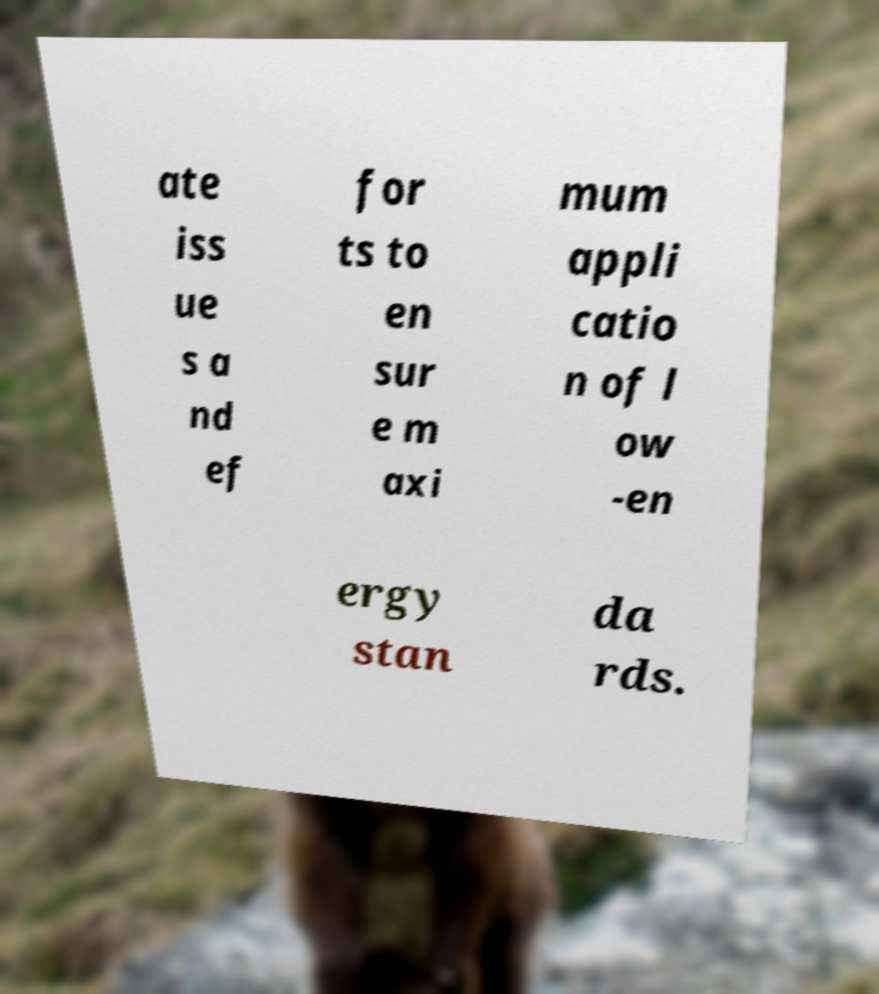Could you assist in decoding the text presented in this image and type it out clearly? ate iss ue s a nd ef for ts to en sur e m axi mum appli catio n of l ow -en ergy stan da rds. 